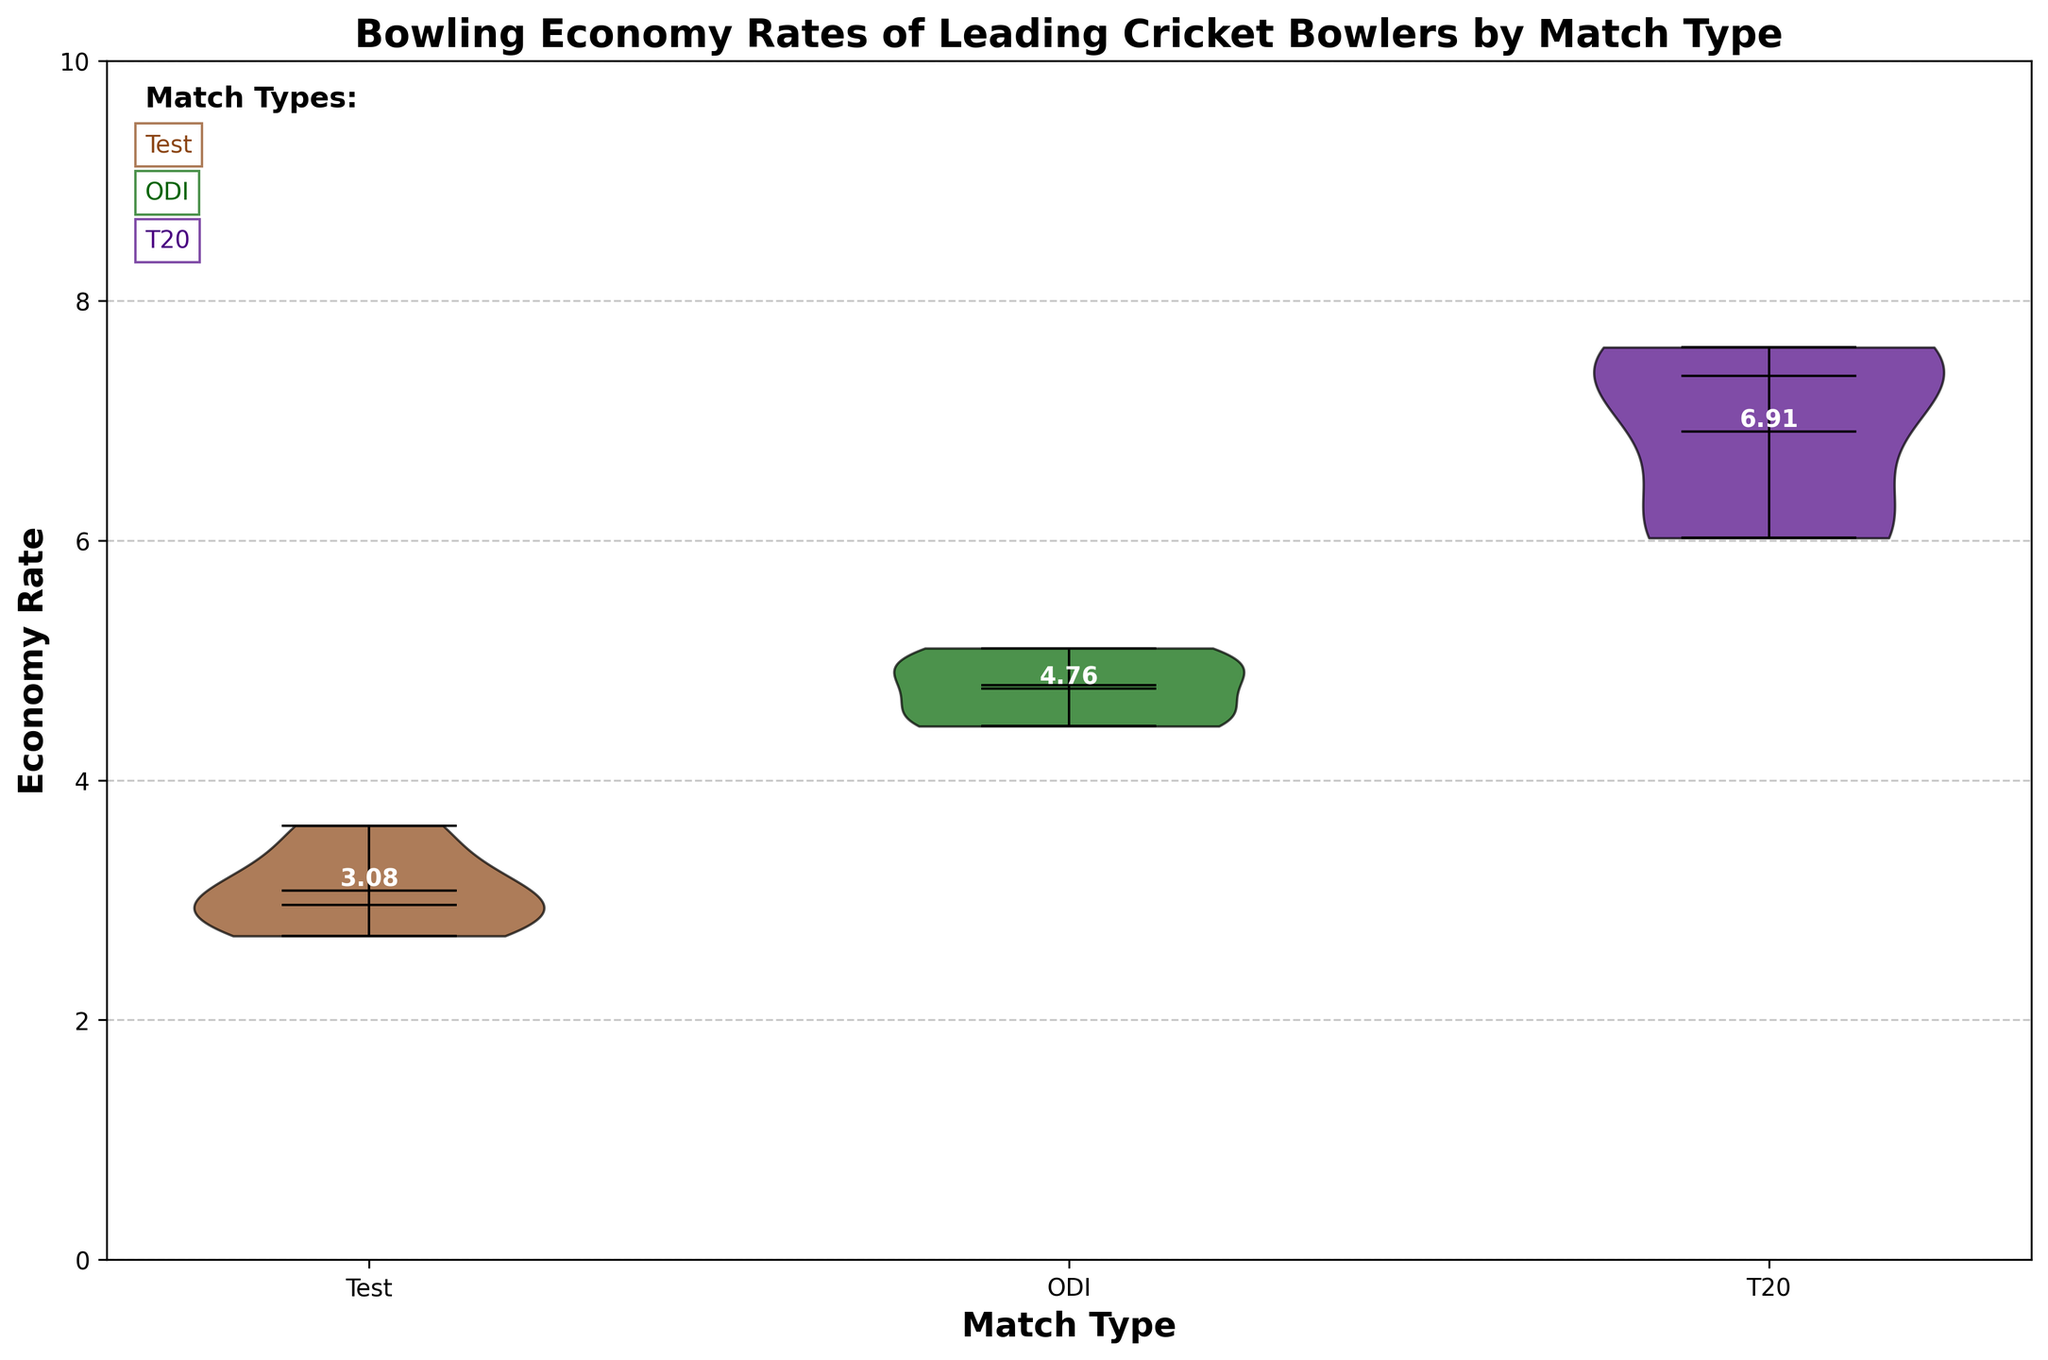What's the title of the plot? The title is written at the top of the chart and states the primary subject of the visualization.
Answer: Bowling Economy Rates of Leading Cricket Bowlers by Match Type Which Match Type has the lowest average economy rate based on the figure? By looking at the annotations above each violin, we can see the mean economy rates. The lowest value is observed over the "Test" category.
Answer: Test What do the colors brown, green, and purple represent in the figure? Each color corresponds to a different match type, as explained by the legend-like text on the top-left of the plot. Brown refers to Test matches, green to ODI, and purple to T20.
Answer: Match Types (Test, ODI, T20) Which bowler has a lower economy rate in both the ODI and T20 formats? By comparing the economy rates of bowlers listed in the ODI and T20 categories, we can see that Jasprit Bumrah has an economy rate of 4.49 in ODI and 7.39 in T20, making his economy rate in ODIs lower.
Answer: Jasprit Bumrah What is the range of economy rates for the T20 match type? The range can be found by looking at the minima and maxima markers of the T20 violin. The lowest value is 6.02 (Sunil Narine) and the highest is 7.61 (Imran Tahir).
Answer: 6.02 to 7.61 Which match type shows the widest spread of economy rates? By comparing the span of the violins, Test matches have the widest spread, indicating more variability in economy rates distributed from ~2.70 to ~3.62.
Answer: Test What's the median economy rate for the ODI match type, and how can you tell? The median is indicated by the central horizontal line within each violin plot. For ODI, it is around 4.79.
Answer: 4.79 What is the mean economy rate for the T20 match type, and where is this shown? The mean is displayed as a marker within each violin plot. In the T20 category, it's annotated and found to be approximately 6.71 (based on visual cues from the added text).
Answer: 6.71 How does the average economy rate of Test matches compare to ODIs? The averages are annotated for each match type: Test ~3.08, ODI ~4.76. By comparing, Test matches have a lower average economy rate.
Answer: Test is lower 